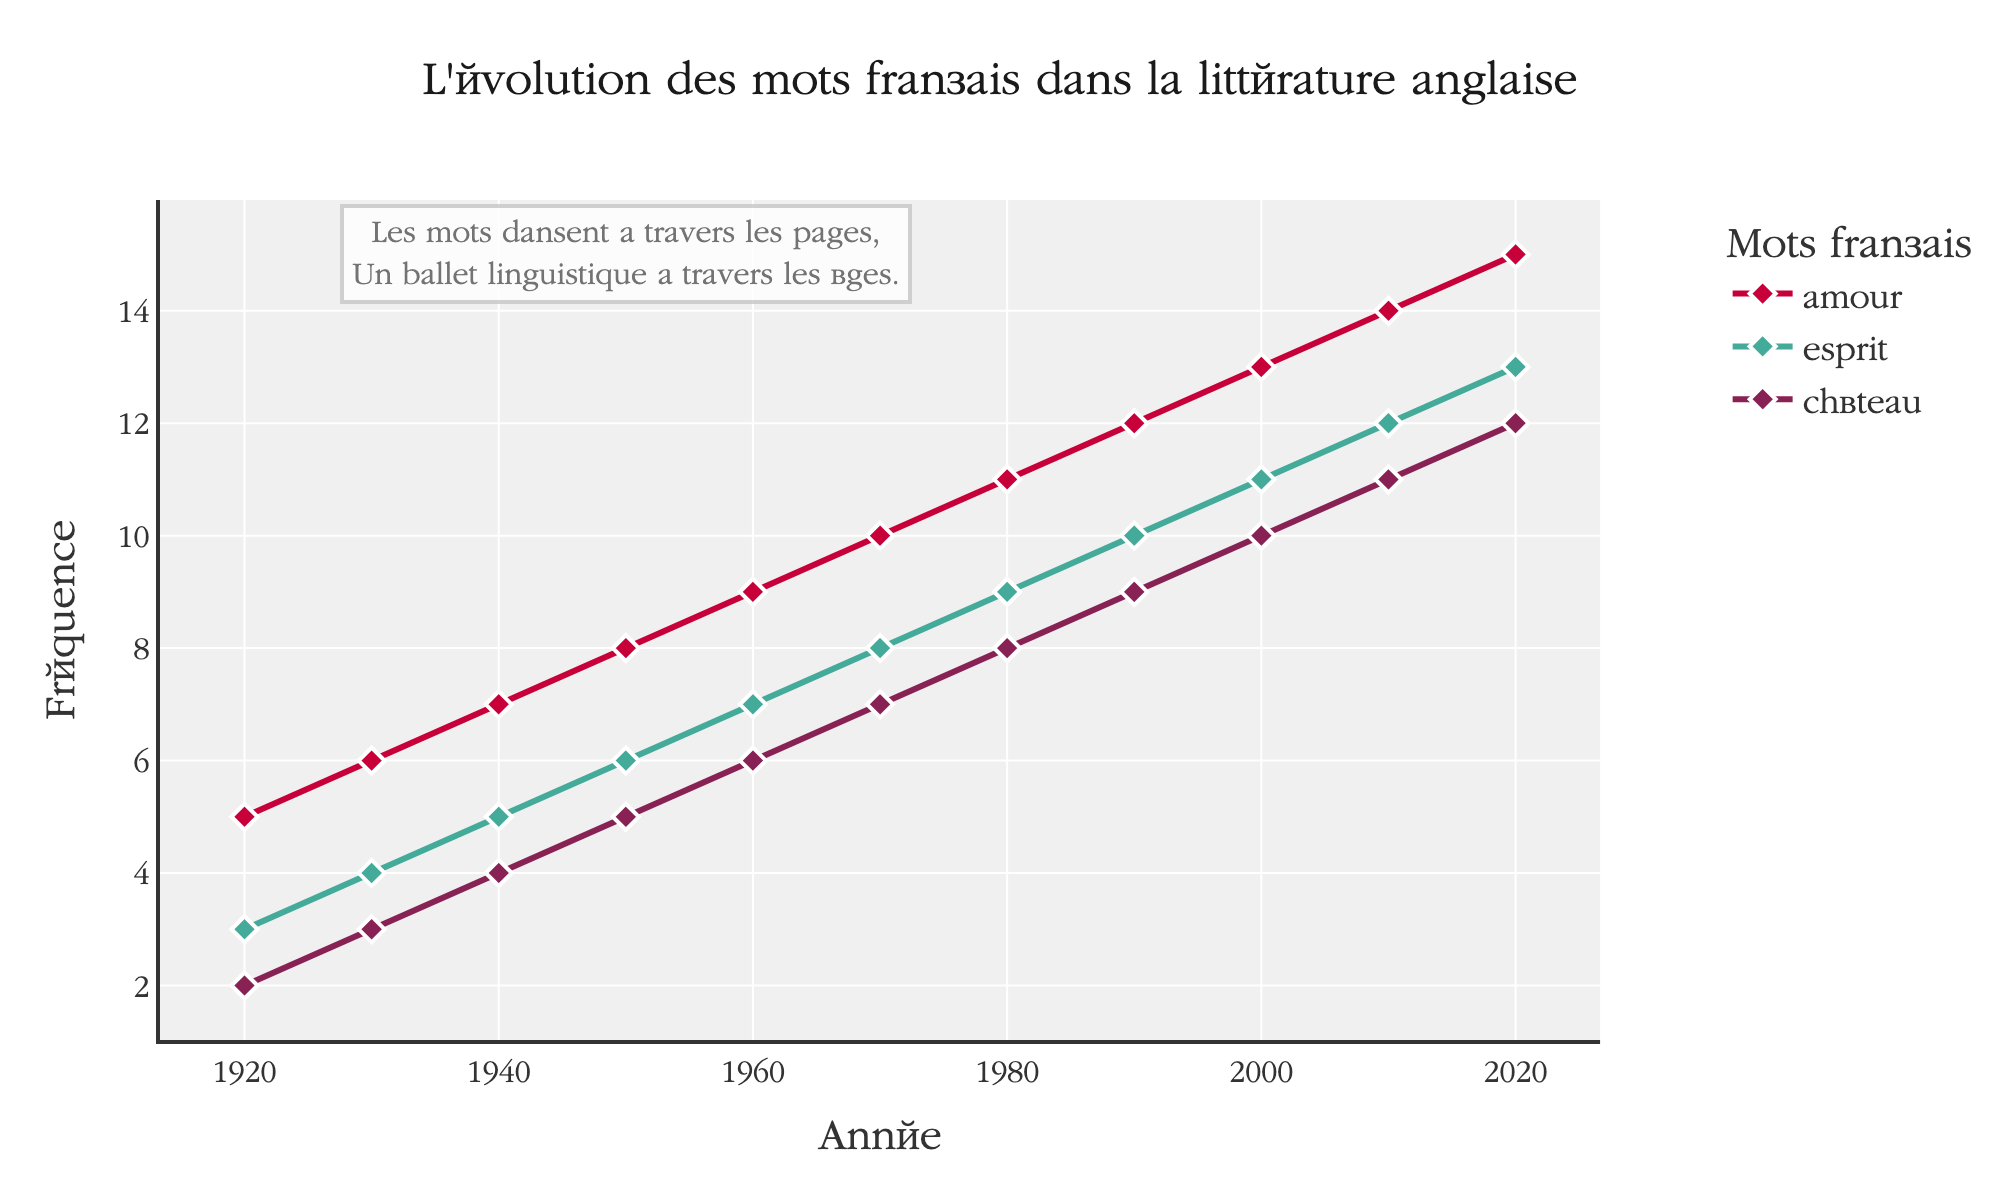What is the title of the figure? The title is positioned towards the top center of the figure, written in a larger font size. It reads "L'évolution des mots français dans la littérature anglaise".
Answer: L'évolution des mots français dans la littérature anglaise How many French words are tracked in the plot? By observing the legend on the right side of the figure, you can see three distinct French words listed. These words are "amour", "esprit", and "château".
Answer: 3 Which French word shows the highest frequency in 2020? Referring to the data points on the rightmost side of the plot for the year 2020, you can see that "amour" has the highest frequency at 15, compared to "esprit" at 13 and "château" at 12.
Answer: amour Between which years did the word "esprit" see its highest increase in frequency? By examining the plot for the "esprit" data line, look for the steepest rise. The increase from 2000 (frequency 11) to 2010 (frequency 12) shows an increment of 1, which is the highest.
Answer: 2000-2010 What is the frequency of the word "château" in 1950? Locate the data point on the plot corresponding to the year 1950 for the "château" line. The value at this point is 5.
Answer: 5 By how much did the frequency of "amour" increase from 1960 to 1980? Look at the "amour" data points for 1960 (frequency 9) and 1980 (frequency 11). Subtract the former from the latter: 11 - 9 = 2.
Answer: 2 Which word's frequency shows a linear growth pattern over the century? Observing the trend lines for each word, "amour" shows a consistent and linear increase in its frequency from 1920 to 2020. The other words show slight deviations.
Answer: amour Calculate the average frequency of the word "esprit" across the entire time period. Sum the frequencies of "esprit" over all the years (3+4+5+6+7+8+9+10+11+12+13 = 88). There are 11 data points (1920 to 2020). Divide the total sum by the number of data points: 88 / 11 = 8.
Answer: 8 In which decade is the frequency change of "château" the smallest? Investigate the "château" data points across each decade. The smallest change occurs between 1960 (frequency 6) and 1970 (frequency 7), showing a change of 1.
Answer: 1960-1970 What poetic annotation is present on the plot? Near the center of the plot, a text annotation reads: "Les mots dansent à travers les pages, Un ballet linguistique à travers les âges."
Answer: Les mots dansent à travers les pages, Un ballet linguistique à travers les âges 